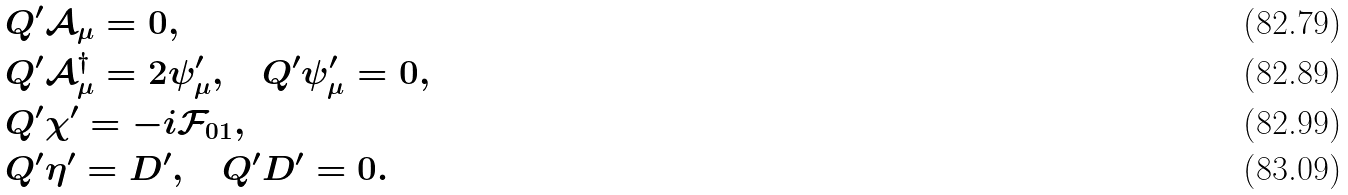<formula> <loc_0><loc_0><loc_500><loc_500>& Q ^ { \prime } \mathcal { A } _ { \mu } = 0 , \\ & Q ^ { \prime } \mathcal { A } _ { \mu } ^ { \dagger } = 2 \psi _ { \mu } ^ { \prime } , \quad Q ^ { \prime } \psi _ { \mu } ^ { \prime } = 0 , \\ & Q ^ { \prime } \chi ^ { \prime } = - i \mathcal { F } _ { 0 1 } , \\ & Q ^ { \prime } \eta ^ { \prime } = D ^ { \prime } , \quad Q ^ { \prime } D ^ { \prime } = 0 .</formula> 